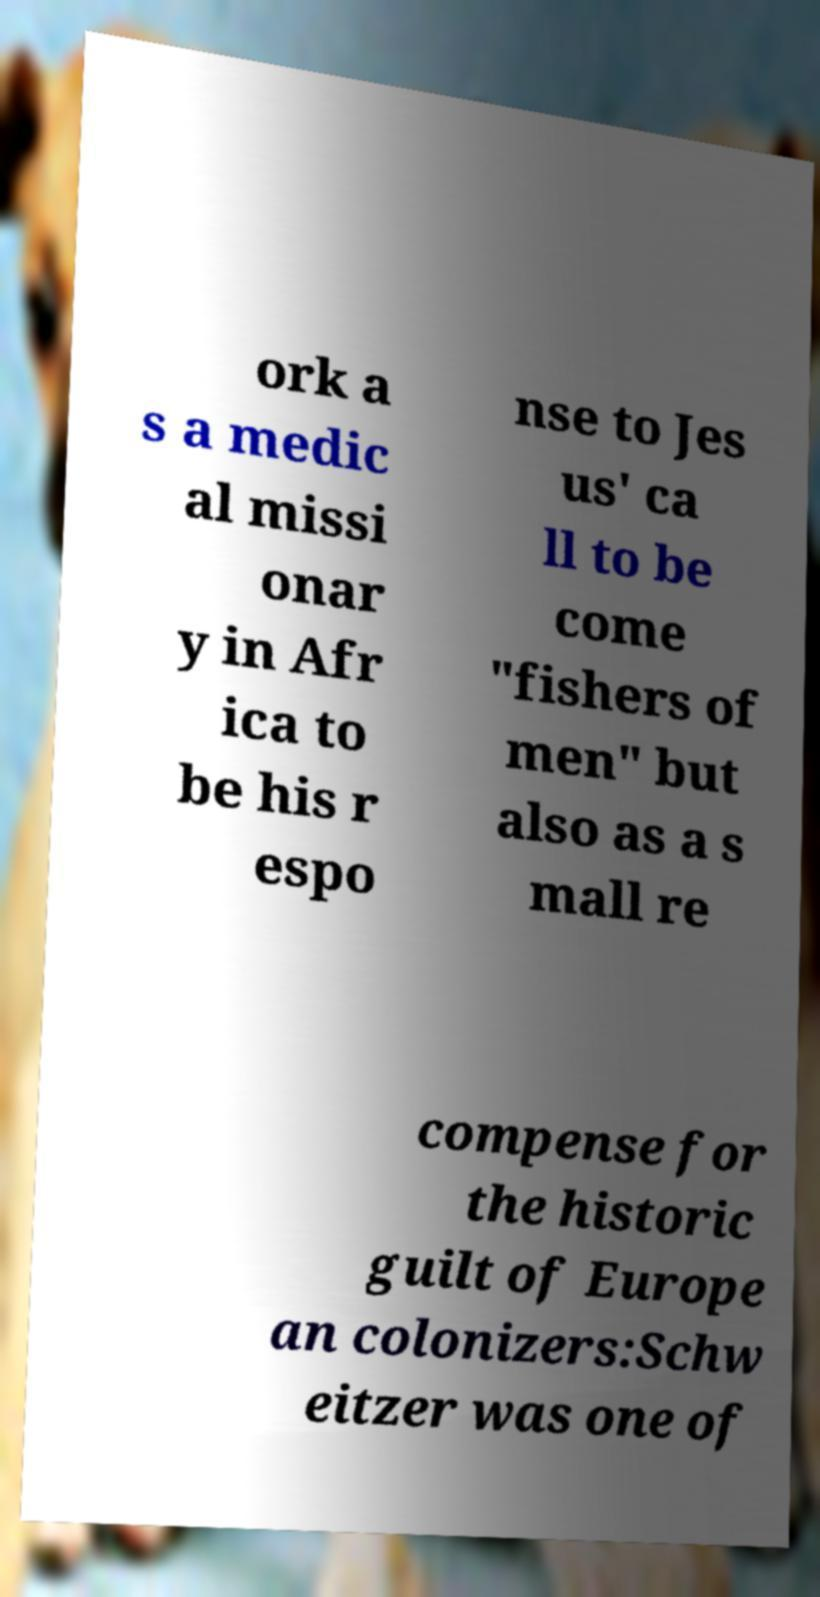There's text embedded in this image that I need extracted. Can you transcribe it verbatim? ork a s a medic al missi onar y in Afr ica to be his r espo nse to Jes us' ca ll to be come "fishers of men" but also as a s mall re compense for the historic guilt of Europe an colonizers:Schw eitzer was one of 